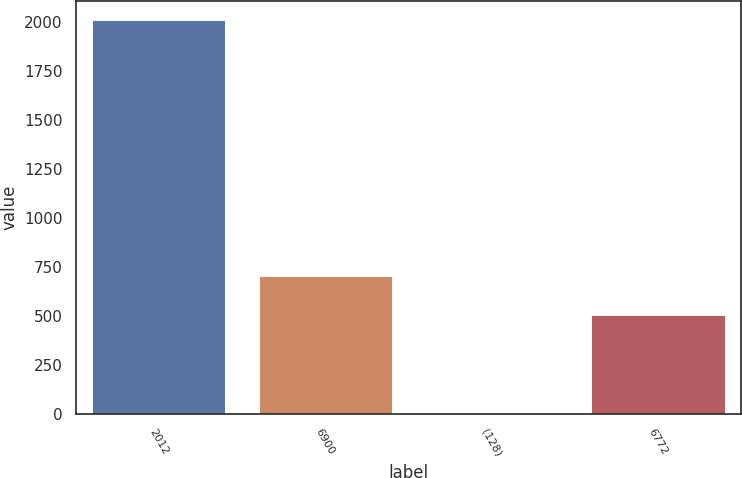Convert chart to OTSL. <chart><loc_0><loc_0><loc_500><loc_500><bar_chart><fcel>2012<fcel>6900<fcel>(128)<fcel>6772<nl><fcel>2010<fcel>703.84<fcel>4.6<fcel>503.3<nl></chart> 